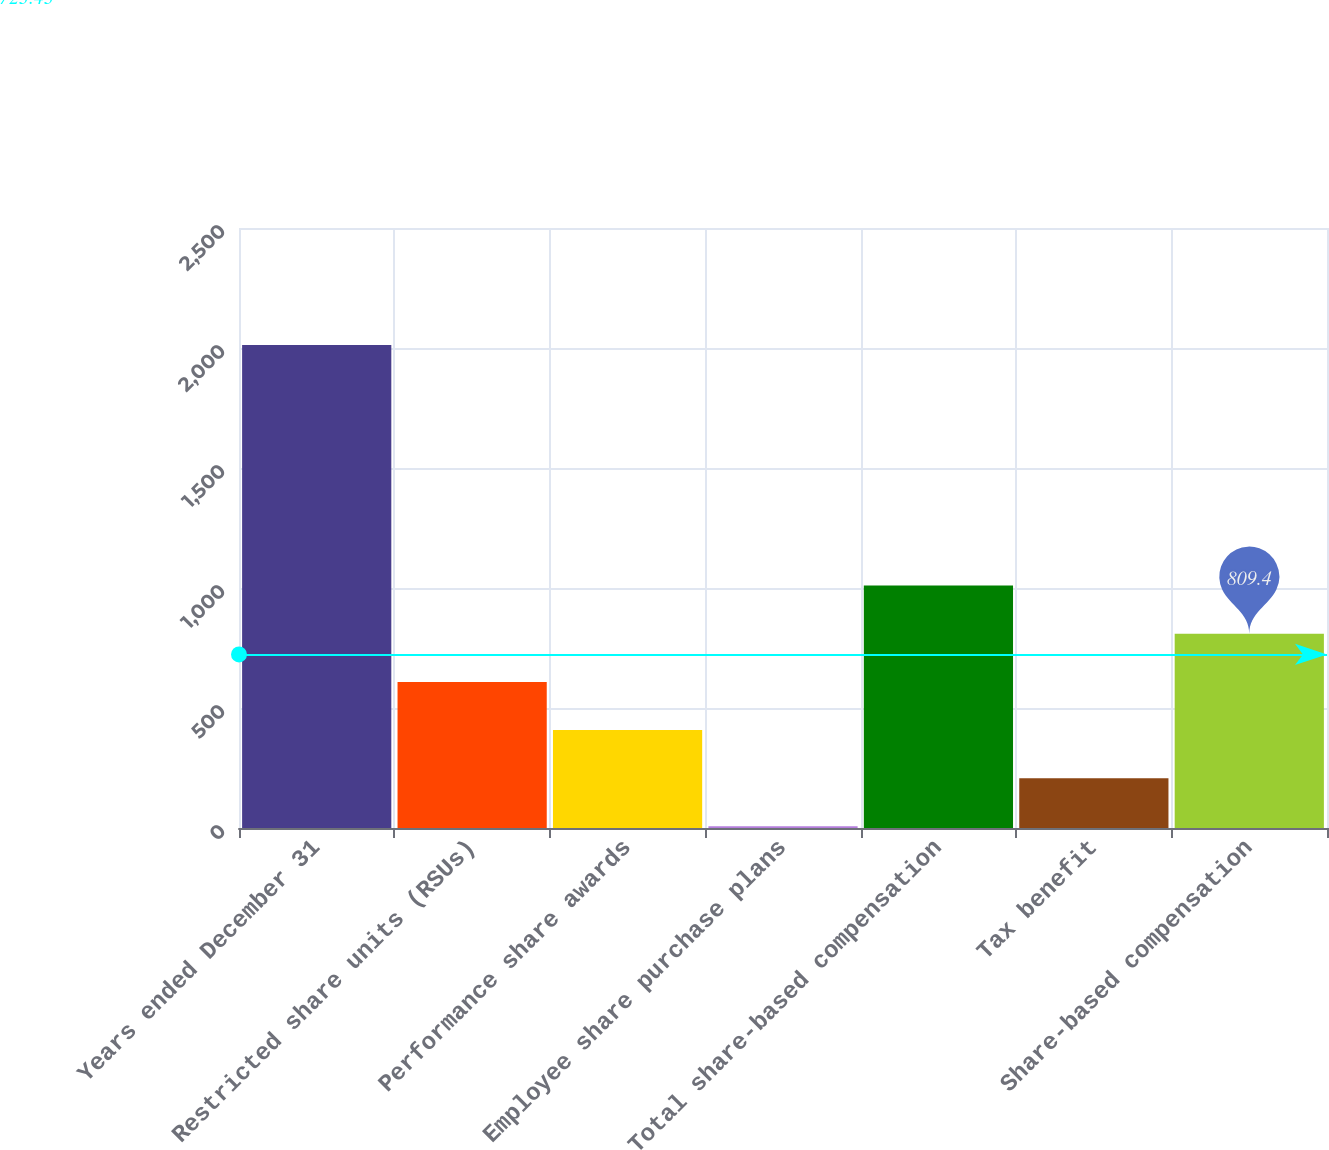<chart> <loc_0><loc_0><loc_500><loc_500><bar_chart><fcel>Years ended December 31<fcel>Restricted share units (RSUs)<fcel>Performance share awards<fcel>Employee share purchase plans<fcel>Total share-based compensation<fcel>Tax benefit<fcel>Share-based compensation<nl><fcel>2013<fcel>608.8<fcel>408.2<fcel>7<fcel>1010<fcel>207.6<fcel>809.4<nl></chart> 